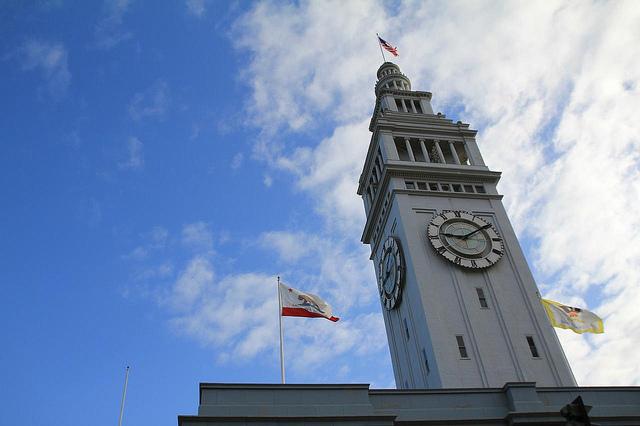What kind of flags are these?
Keep it brief. State. What time is on the clock?
Write a very short answer. 9:10. What color is the flag on the top of the building?
Give a very brief answer. Red, white, blue. Are there any clouds in the sky?
Quick response, please. Yes. 